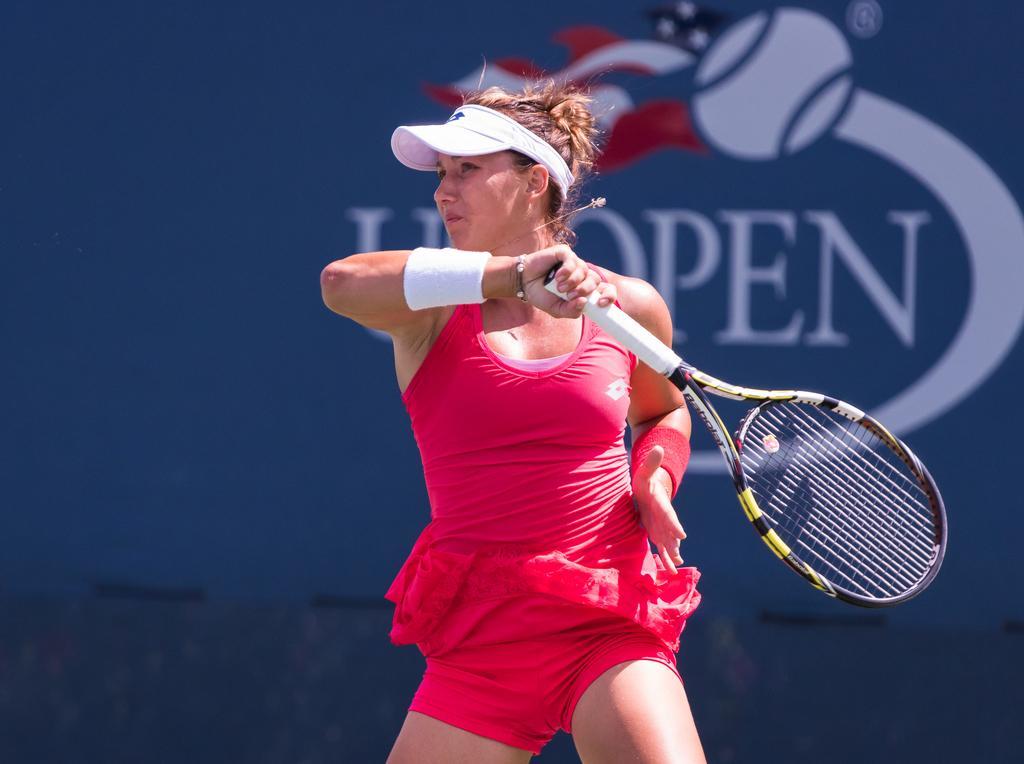In one or two sentences, can you explain what this image depicts? In this image there is one woman who is playing tennis and she is holding a racket, and on the background there is one poster. 